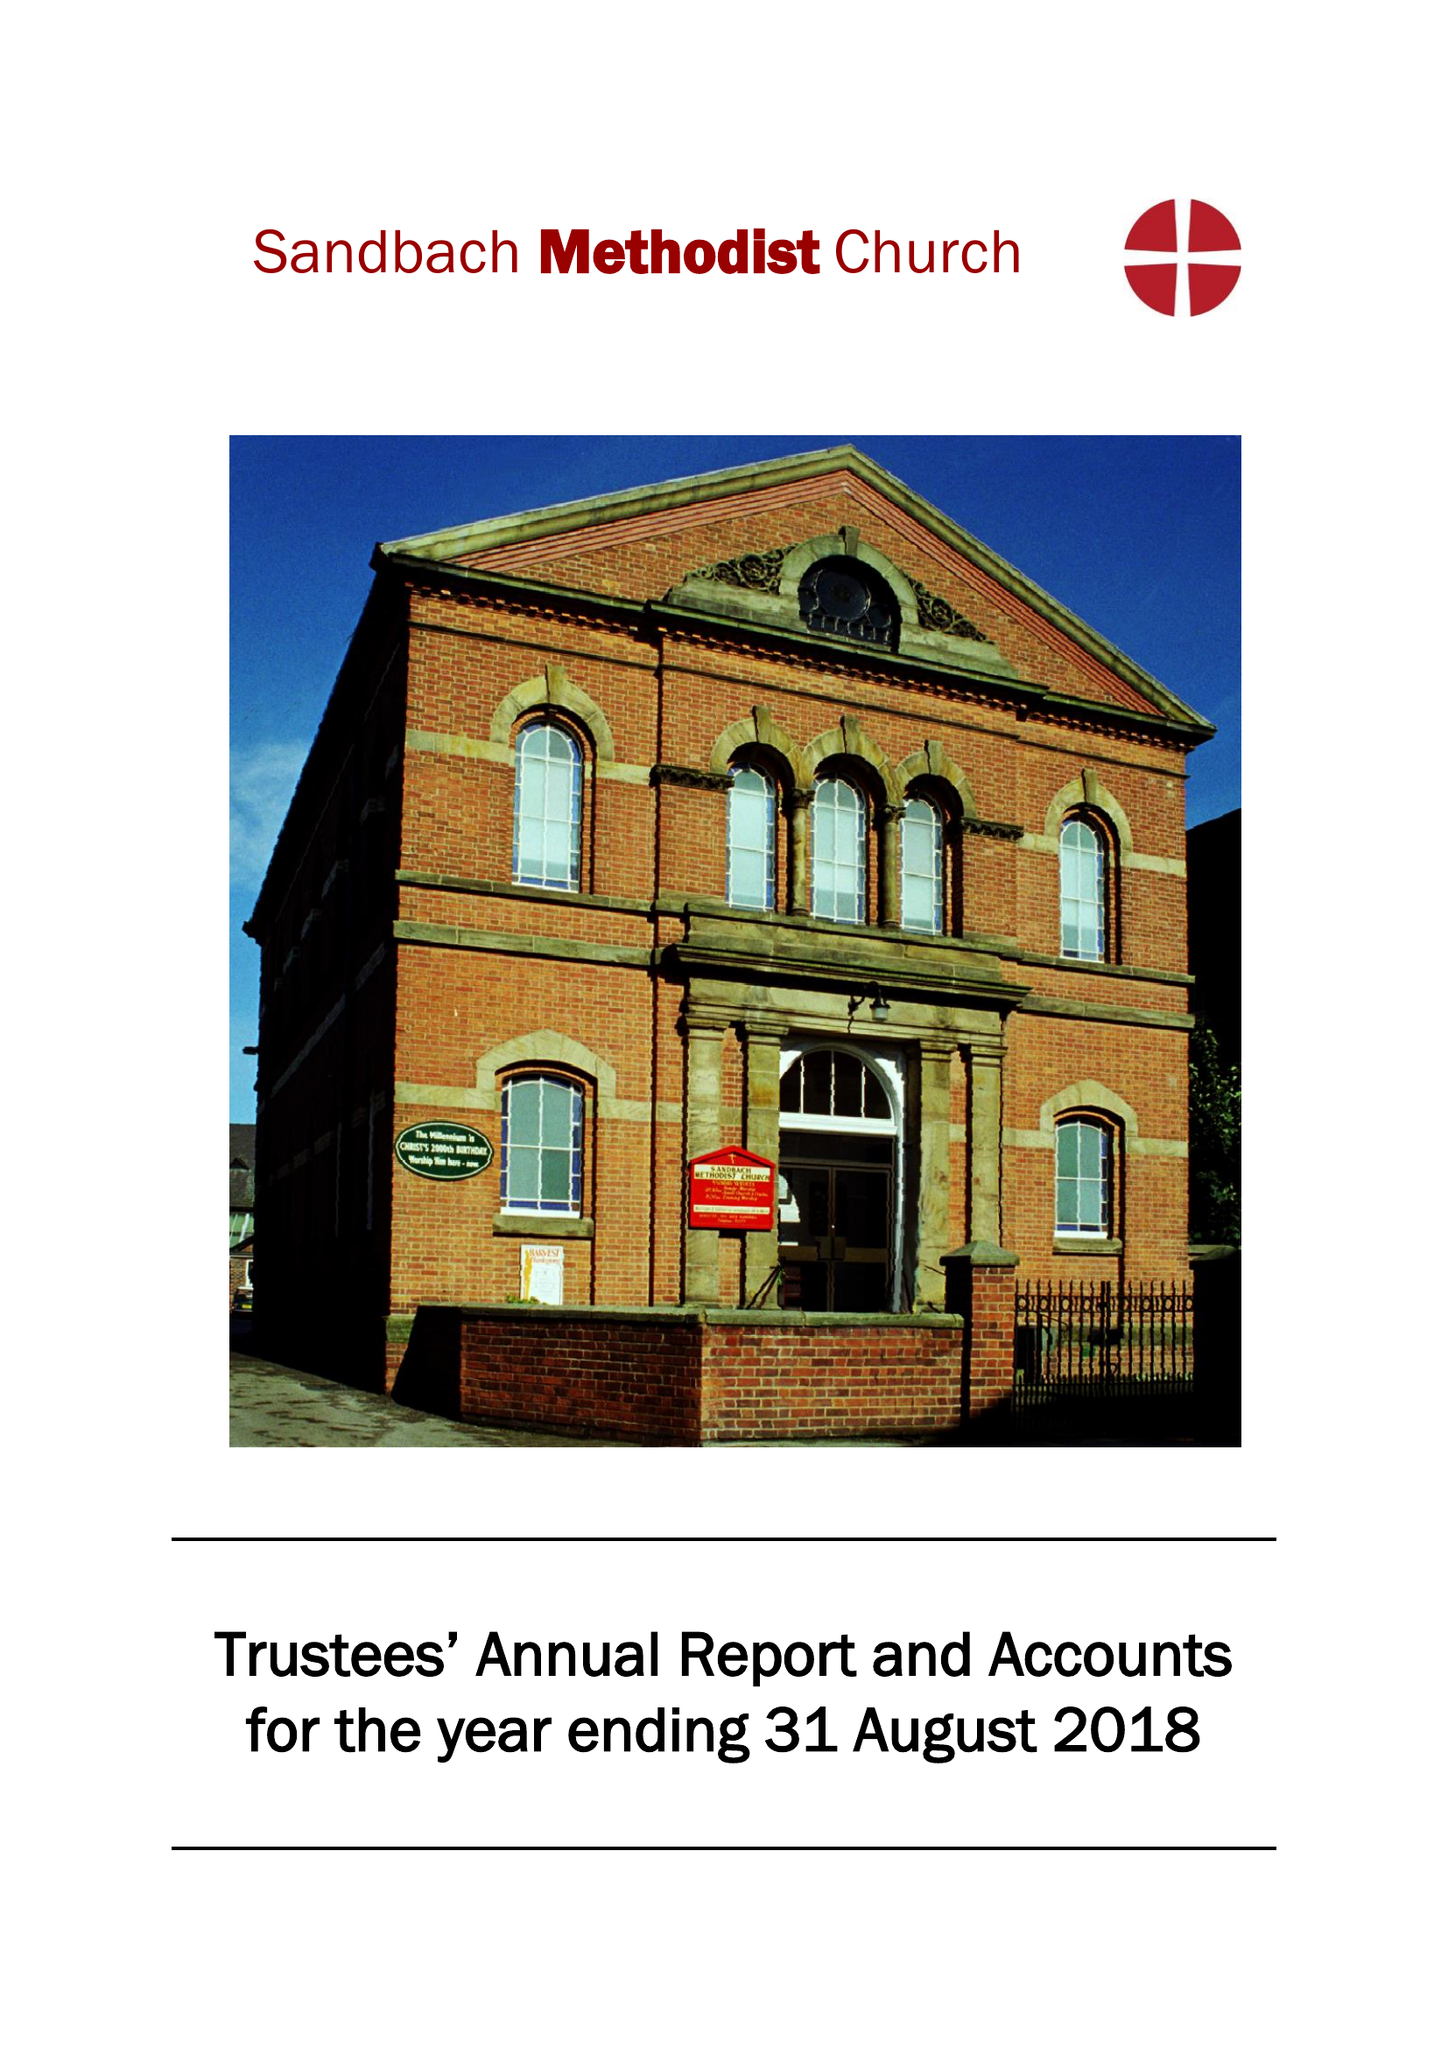What is the value for the address__street_line?
Answer the question using a single word or phrase. WESLEY AVENUE 